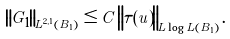<formula> <loc_0><loc_0><loc_500><loc_500>\left \| G _ { 1 } \right \| _ { L ^ { 2 , 1 } ( B _ { 1 } ) } \leq C \left \| \tau ( u ) \right \| _ { L \log L ( B _ { 1 } ) } .</formula> 